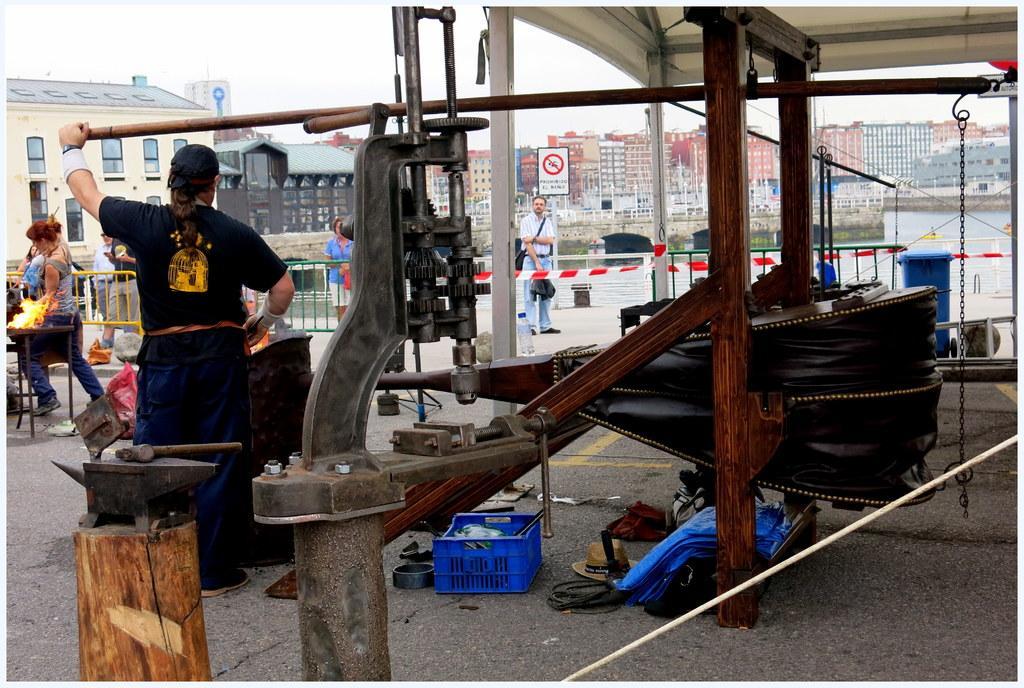Can you describe this image briefly? In front of the image there is a wooden log with a tool on it. Beside that there is a machine. And also there are wooden poles with equipment. And there is a person holding the wooden object. And there are few people in the image. On the left corner of the image there is a table with fire. And in the background there are buildings, pole with a sign board, railings, walls, water and chain. On the ground there is a box, cover, hat and some other things. 